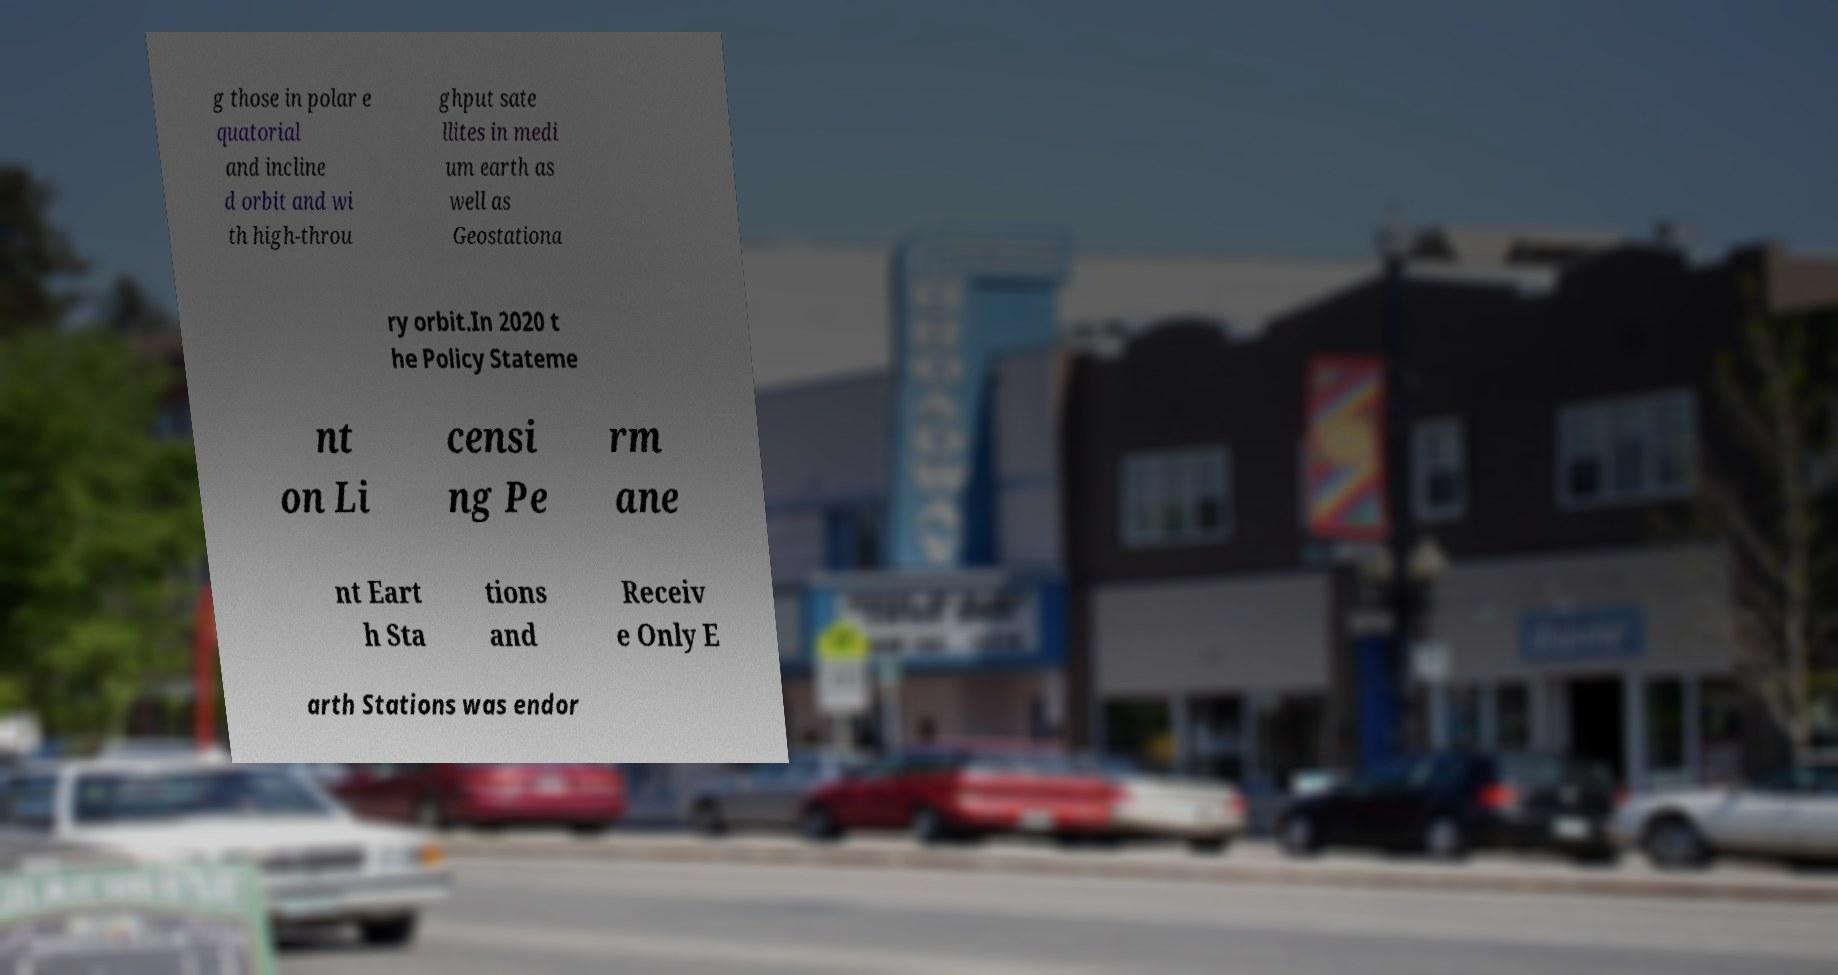Can you accurately transcribe the text from the provided image for me? g those in polar e quatorial and incline d orbit and wi th high-throu ghput sate llites in medi um earth as well as Geostationa ry orbit.In 2020 t he Policy Stateme nt on Li censi ng Pe rm ane nt Eart h Sta tions and Receiv e Only E arth Stations was endor 